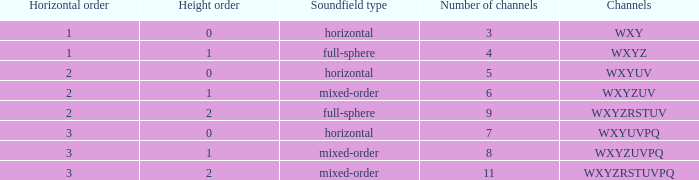If the height order is 1 and the soundfield type is mixed-order, what are all the channels? WXYZUV, WXYZUVPQ. 